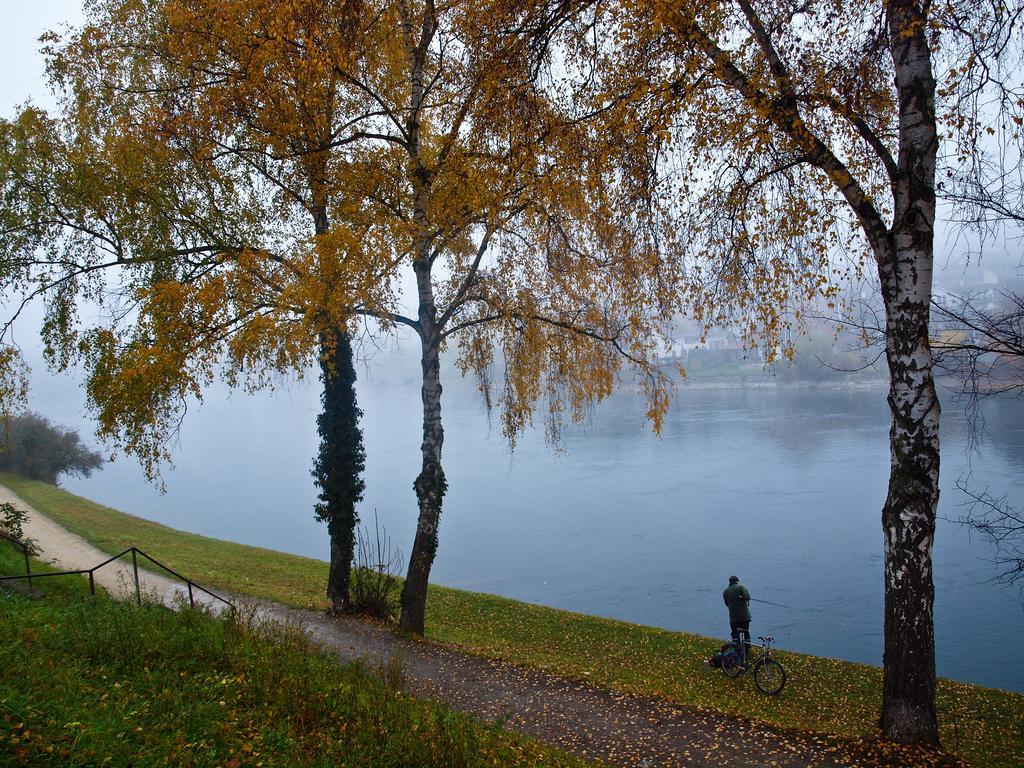Can you describe this image briefly? In this image we can see a person standing on the grass. We can also see a bicycle. Image also consists of trees, fence, plants and also the lake. We can also see the dried leaves on the ground. 